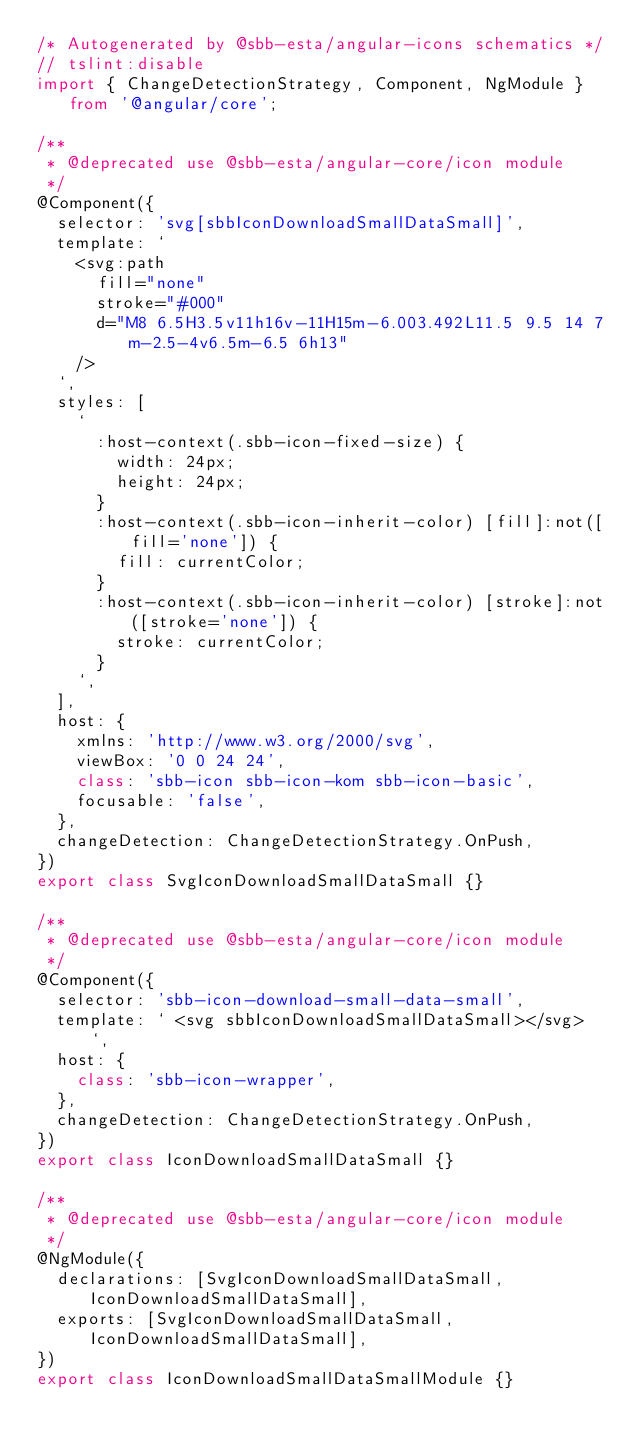<code> <loc_0><loc_0><loc_500><loc_500><_TypeScript_>/* Autogenerated by @sbb-esta/angular-icons schematics */
// tslint:disable
import { ChangeDetectionStrategy, Component, NgModule } from '@angular/core';

/**
 * @deprecated use @sbb-esta/angular-core/icon module
 */
@Component({
  selector: 'svg[sbbIconDownloadSmallDataSmall]',
  template: `
    <svg:path
      fill="none"
      stroke="#000"
      d="M8 6.5H3.5v11h16v-11H15m-6.003.492L11.5 9.5 14 7m-2.5-4v6.5m-6.5 6h13"
    />
  `,
  styles: [
    `
      :host-context(.sbb-icon-fixed-size) {
        width: 24px;
        height: 24px;
      }
      :host-context(.sbb-icon-inherit-color) [fill]:not([fill='none']) {
        fill: currentColor;
      }
      :host-context(.sbb-icon-inherit-color) [stroke]:not([stroke='none']) {
        stroke: currentColor;
      }
    `,
  ],
  host: {
    xmlns: 'http://www.w3.org/2000/svg',
    viewBox: '0 0 24 24',
    class: 'sbb-icon sbb-icon-kom sbb-icon-basic',
    focusable: 'false',
  },
  changeDetection: ChangeDetectionStrategy.OnPush,
})
export class SvgIconDownloadSmallDataSmall {}

/**
 * @deprecated use @sbb-esta/angular-core/icon module
 */
@Component({
  selector: 'sbb-icon-download-small-data-small',
  template: ` <svg sbbIconDownloadSmallDataSmall></svg> `,
  host: {
    class: 'sbb-icon-wrapper',
  },
  changeDetection: ChangeDetectionStrategy.OnPush,
})
export class IconDownloadSmallDataSmall {}

/**
 * @deprecated use @sbb-esta/angular-core/icon module
 */
@NgModule({
  declarations: [SvgIconDownloadSmallDataSmall, IconDownloadSmallDataSmall],
  exports: [SvgIconDownloadSmallDataSmall, IconDownloadSmallDataSmall],
})
export class IconDownloadSmallDataSmallModule {}
</code> 